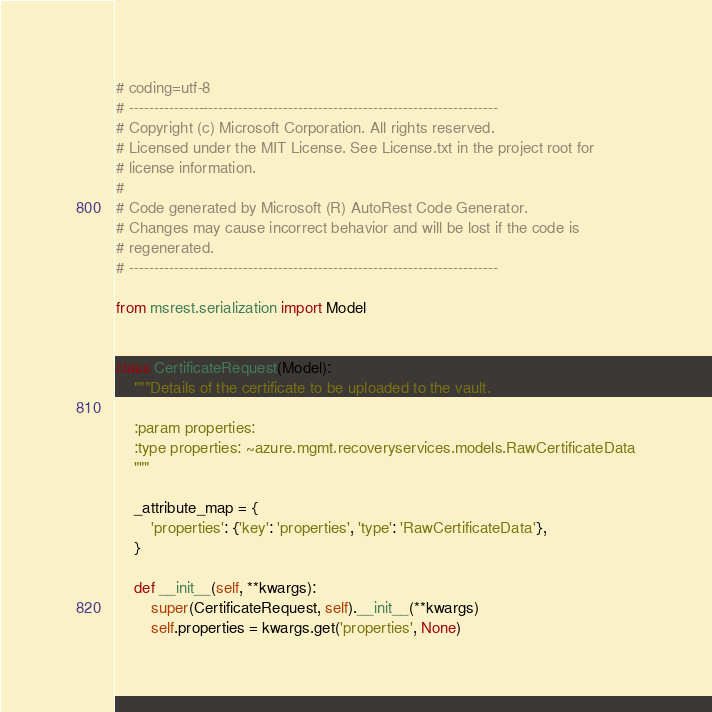Convert code to text. <code><loc_0><loc_0><loc_500><loc_500><_Python_># coding=utf-8
# --------------------------------------------------------------------------
# Copyright (c) Microsoft Corporation. All rights reserved.
# Licensed under the MIT License. See License.txt in the project root for
# license information.
#
# Code generated by Microsoft (R) AutoRest Code Generator.
# Changes may cause incorrect behavior and will be lost if the code is
# regenerated.
# --------------------------------------------------------------------------

from msrest.serialization import Model


class CertificateRequest(Model):
    """Details of the certificate to be uploaded to the vault.

    :param properties:
    :type properties: ~azure.mgmt.recoveryservices.models.RawCertificateData
    """

    _attribute_map = {
        'properties': {'key': 'properties', 'type': 'RawCertificateData'},
    }

    def __init__(self, **kwargs):
        super(CertificateRequest, self).__init__(**kwargs)
        self.properties = kwargs.get('properties', None)
</code> 